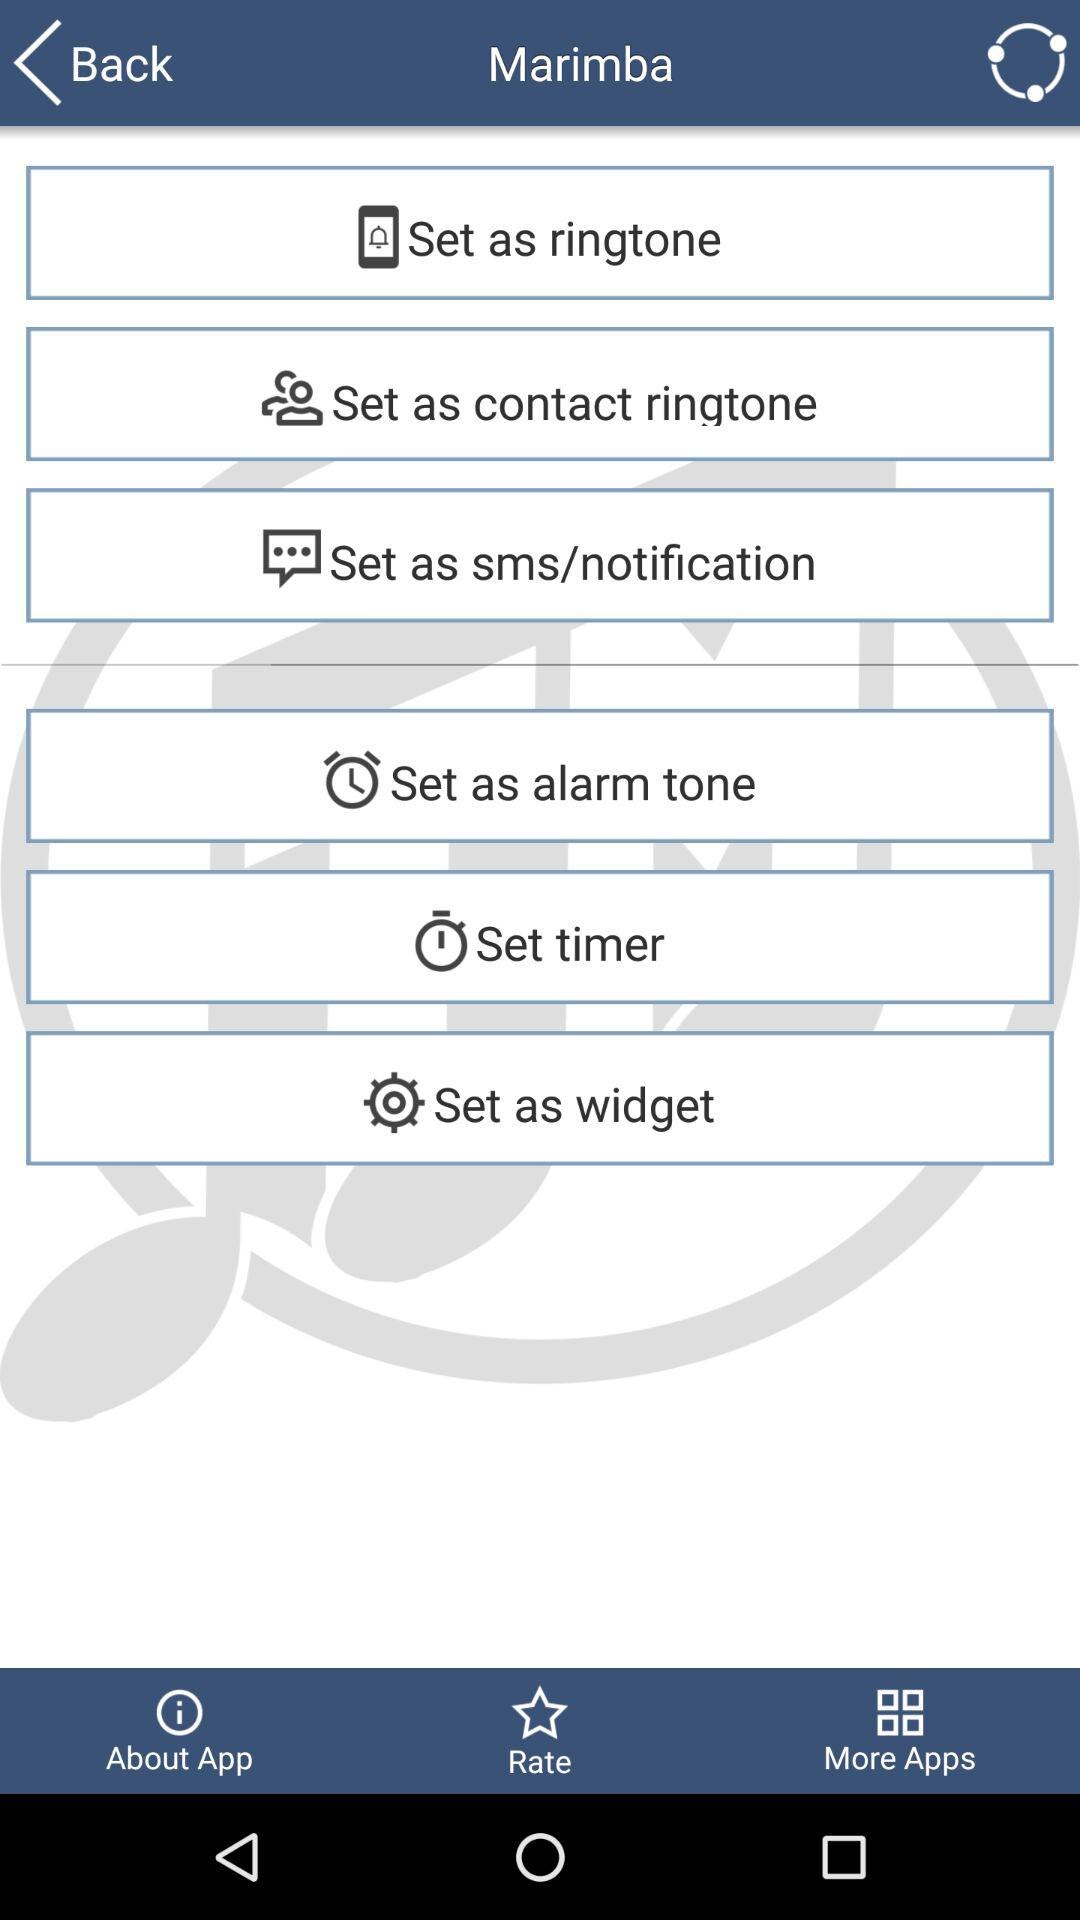What is the application name? The application name is "Marimba". 